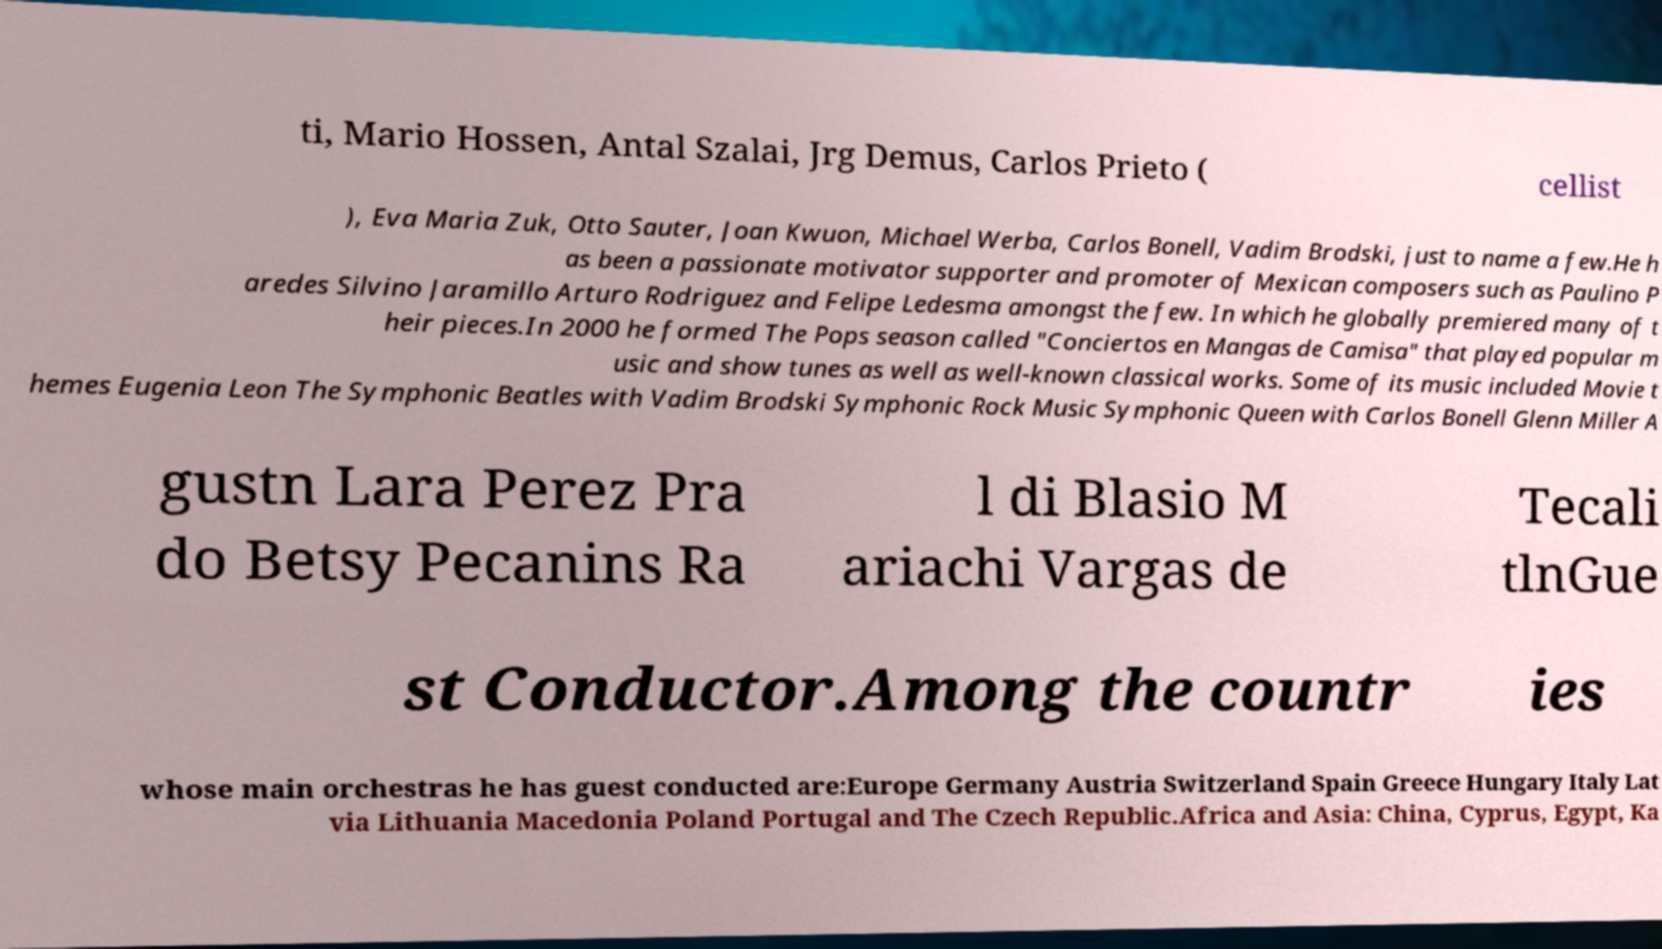Can you accurately transcribe the text from the provided image for me? ti, Mario Hossen, Antal Szalai, Jrg Demus, Carlos Prieto ( cellist ), Eva Maria Zuk, Otto Sauter, Joan Kwuon, Michael Werba, Carlos Bonell, Vadim Brodski, just to name a few.He h as been a passionate motivator supporter and promoter of Mexican composers such as Paulino P aredes Silvino Jaramillo Arturo Rodriguez and Felipe Ledesma amongst the few. In which he globally premiered many of t heir pieces.In 2000 he formed The Pops season called "Conciertos en Mangas de Camisa" that played popular m usic and show tunes as well as well-known classical works. Some of its music included Movie t hemes Eugenia Leon The Symphonic Beatles with Vadim Brodski Symphonic Rock Music Symphonic Queen with Carlos Bonell Glenn Miller A gustn Lara Perez Pra do Betsy Pecanins Ra l di Blasio M ariachi Vargas de Tecali tlnGue st Conductor.Among the countr ies whose main orchestras he has guest conducted are:Europe Germany Austria Switzerland Spain Greece Hungary Italy Lat via Lithuania Macedonia Poland Portugal and The Czech Republic.Africa and Asia: China, Cyprus, Egypt, Ka 